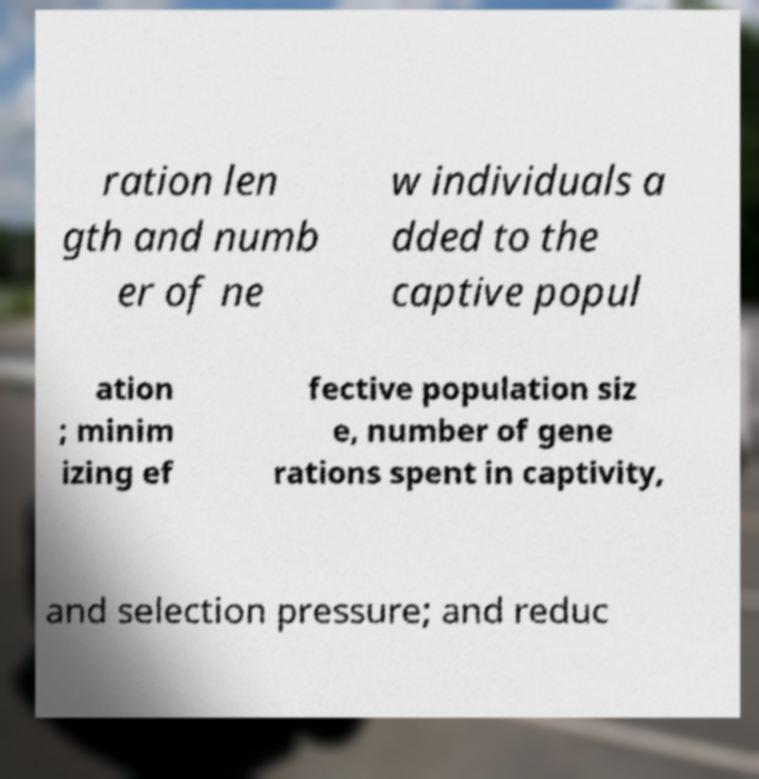Could you assist in decoding the text presented in this image and type it out clearly? ration len gth and numb er of ne w individuals a dded to the captive popul ation ; minim izing ef fective population siz e, number of gene rations spent in captivity, and selection pressure; and reduc 